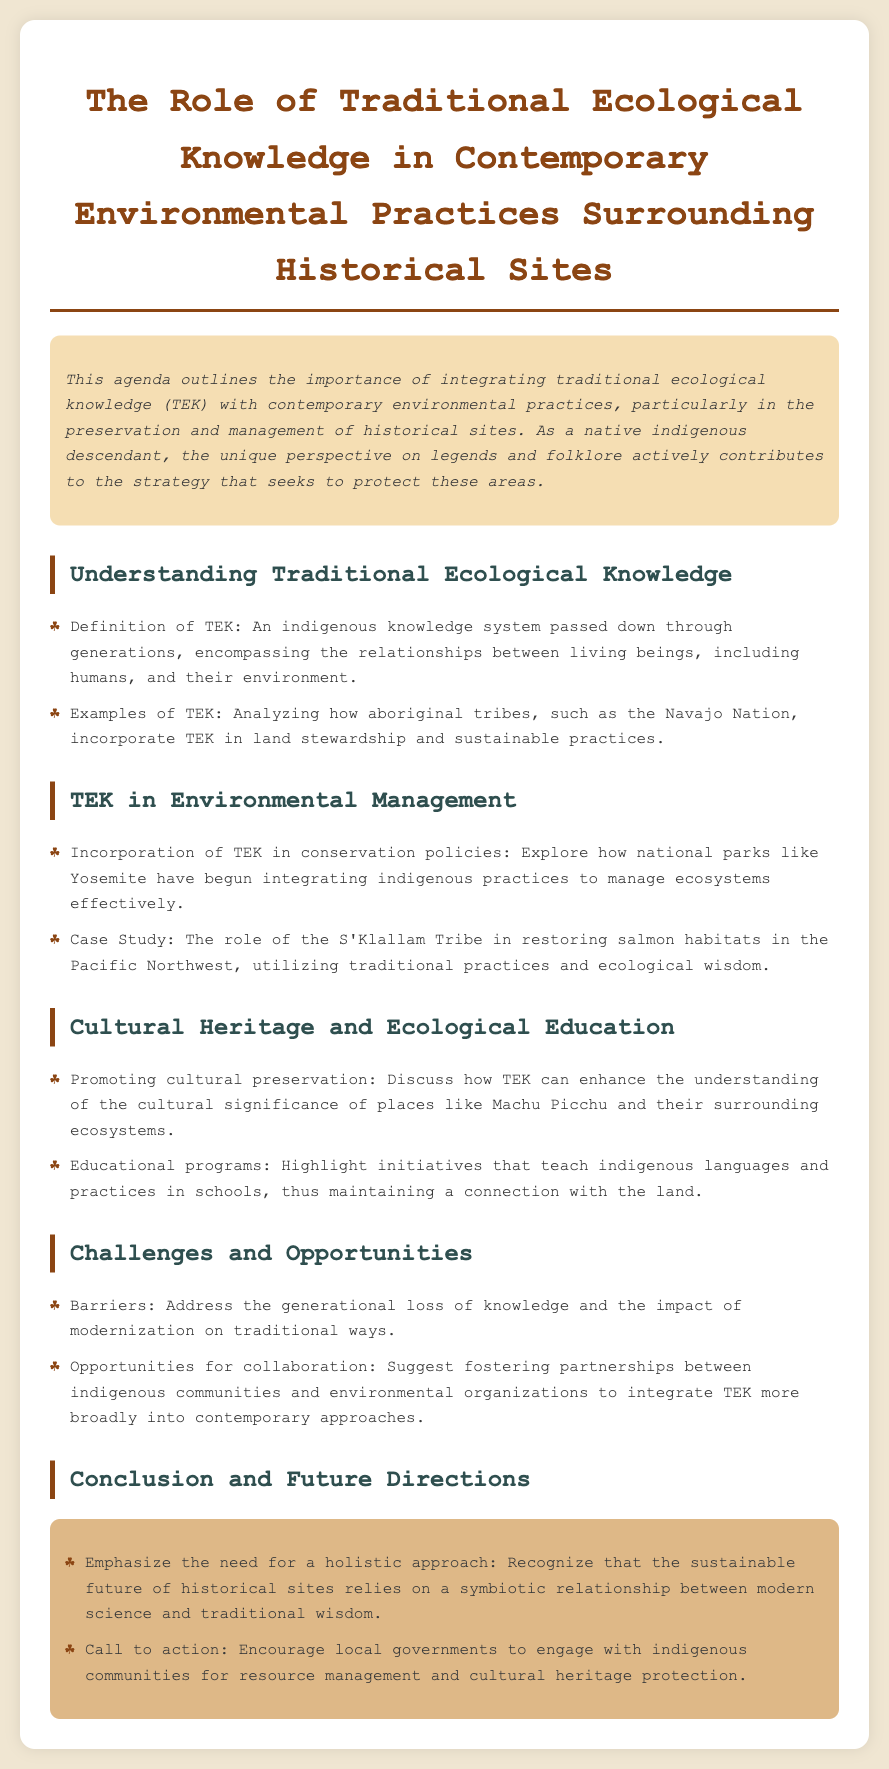What is the main theme of the agenda? The main theme of the agenda is the integration of traditional ecological knowledge with contemporary environmental practices regarding historical sites.
Answer: Integration of traditional ecological knowledge What example of TEK is mentioned? The agenda provides an example of the Navajo Nation and its incorporation of TEK in land stewardship and sustainable practices.
Answer: Navajo Nation Which national park is mentioned in relation to TEK incorporation? Yosemite National Park is discussed regarding its integration of indigenous practices for effective ecosystem management.
Answer: Yosemite What challenge is highlighted concerning traditional knowledge? The generational loss of knowledge is identified as a significant barrier affecting traditional ecological knowledge.
Answer: Generational loss What opportunity is suggested in the agenda? The agenda suggests fostering partnerships between indigenous communities and environmental organizations to integrate TEK into contemporary practices.
Answer: Partnerships How is cultural preservation promoted through TEK? The agenda discusses enhancing the understanding of the cultural significance of places like Machu Picchu and their ecosystems through TEK.
Answer: Cultural significance What is the call to action in the conclusion? The conclusion calls for local governments to engage with indigenous communities for resource management and cultural heritage protection.
Answer: Engage with indigenous communities How does the agenda describe TEK? TEK is described as an indigenous knowledge system passed down through generations, encompassing the relationships between living beings and their environment.
Answer: Indigenous knowledge system What type of programs are mentioned for educational purposes? The agenda highlights educational programs that teach indigenous languages and practices in schools.
Answer: Educational programs 